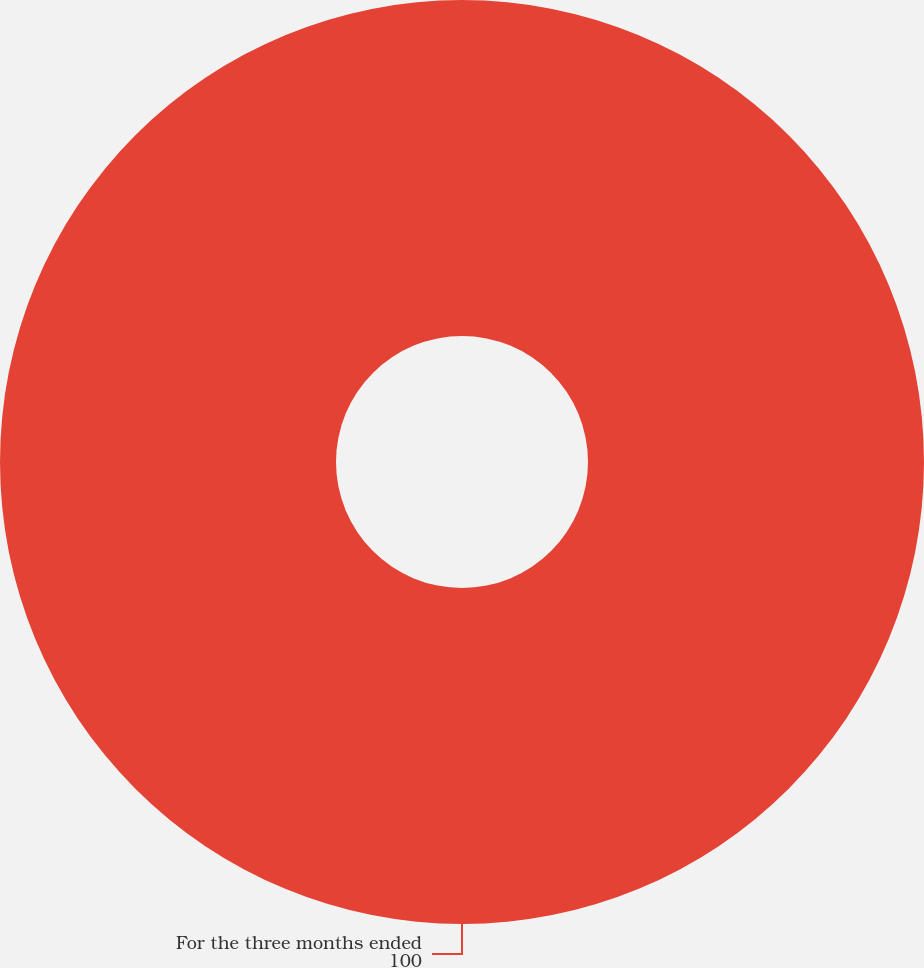<chart> <loc_0><loc_0><loc_500><loc_500><pie_chart><fcel>For the three months ended<nl><fcel>100.0%<nl></chart> 